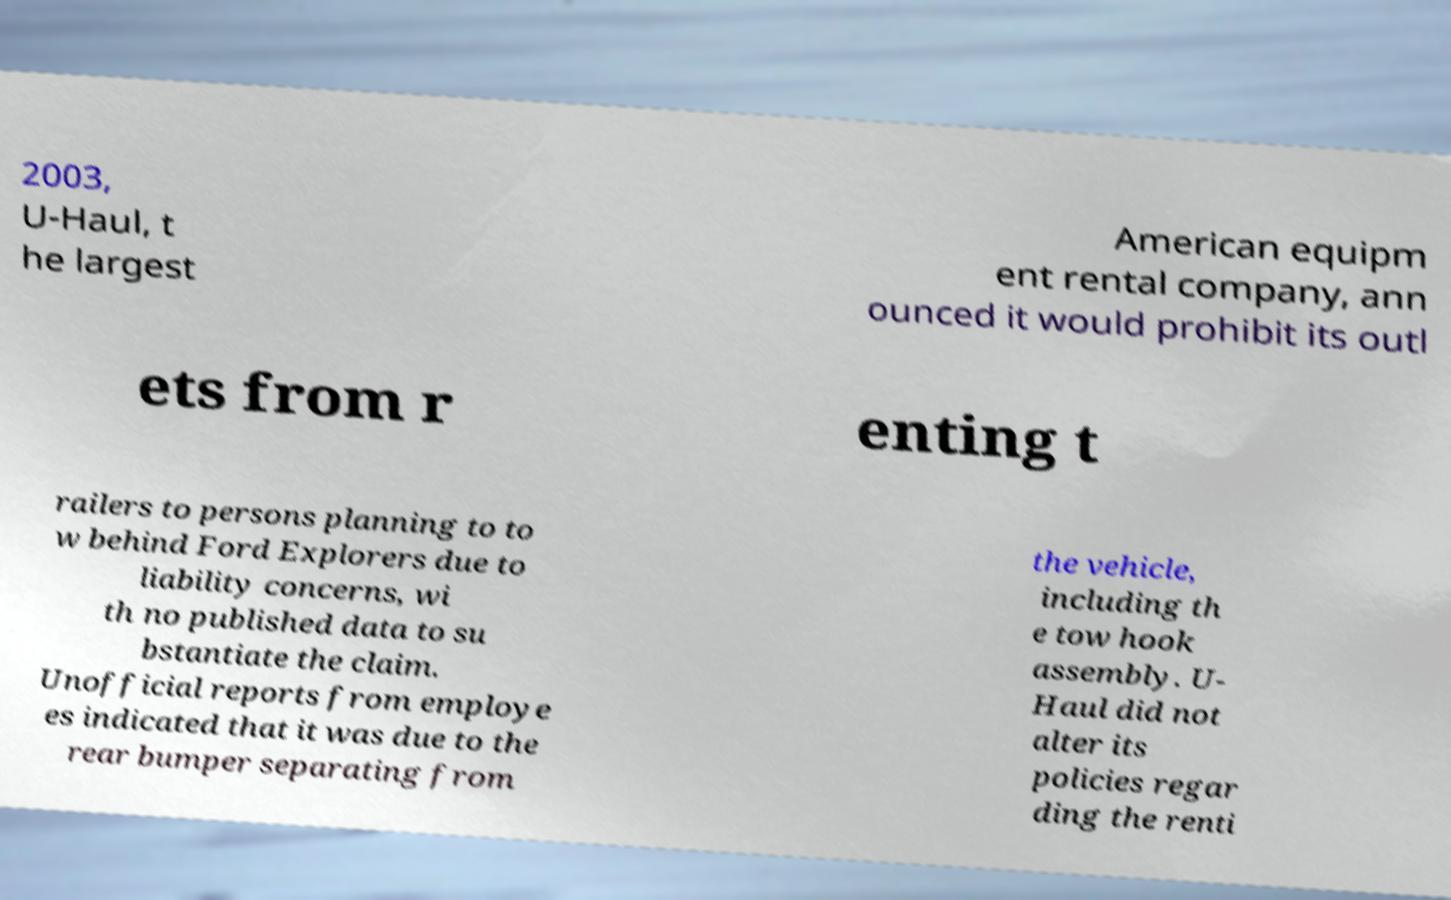There's text embedded in this image that I need extracted. Can you transcribe it verbatim? 2003, U-Haul, t he largest American equipm ent rental company, ann ounced it would prohibit its outl ets from r enting t railers to persons planning to to w behind Ford Explorers due to liability concerns, wi th no published data to su bstantiate the claim. Unofficial reports from employe es indicated that it was due to the rear bumper separating from the vehicle, including th e tow hook assembly. U- Haul did not alter its policies regar ding the renti 